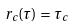<formula> <loc_0><loc_0><loc_500><loc_500>r _ { c } ( \tau ) = \tau _ { c }</formula> 